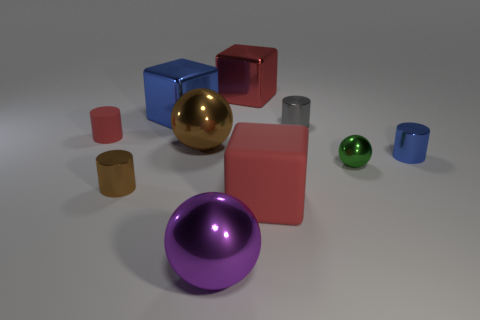Subtract 1 cylinders. How many cylinders are left? 3 Subtract all cylinders. How many objects are left? 6 Add 8 big red matte things. How many big red matte things exist? 9 Subtract 0 purple cylinders. How many objects are left? 10 Subtract all brown balls. Subtract all small brown metal things. How many objects are left? 8 Add 1 tiny brown cylinders. How many tiny brown cylinders are left? 2 